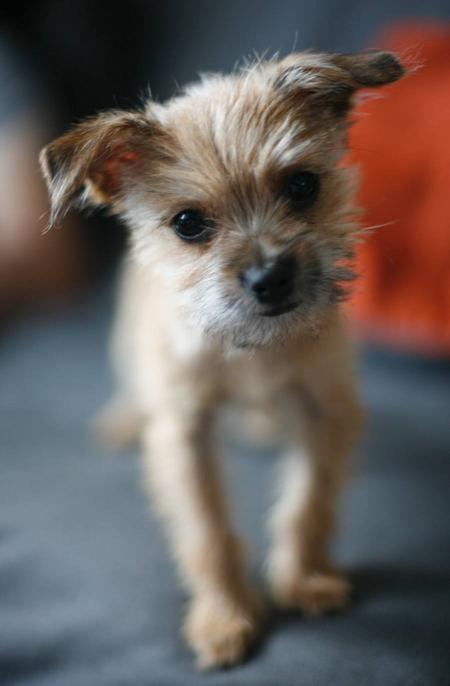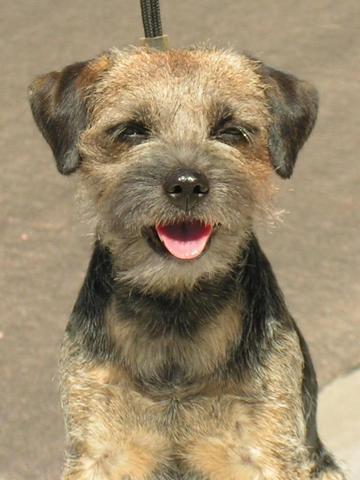The first image is the image on the left, the second image is the image on the right. For the images shown, is this caption "One image shows a dog whose mouth isn't fully closed." true? Answer yes or no. Yes. The first image is the image on the left, the second image is the image on the right. Considering the images on both sides, is "One of the dogs has a body part that is normally inside the mouth being shown outside of the mouth." valid? Answer yes or no. Yes. 